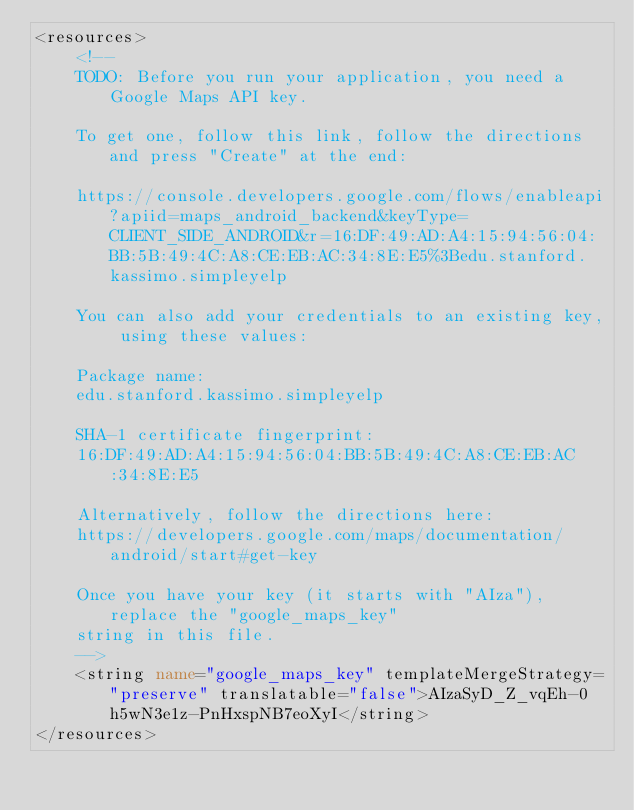<code> <loc_0><loc_0><loc_500><loc_500><_XML_><resources>
    <!--
    TODO: Before you run your application, you need a Google Maps API key.

    To get one, follow this link, follow the directions and press "Create" at the end:

    https://console.developers.google.com/flows/enableapi?apiid=maps_android_backend&keyType=CLIENT_SIDE_ANDROID&r=16:DF:49:AD:A4:15:94:56:04:BB:5B:49:4C:A8:CE:EB:AC:34:8E:E5%3Bedu.stanford.kassimo.simpleyelp

    You can also add your credentials to an existing key, using these values:

    Package name:
    edu.stanford.kassimo.simpleyelp

    SHA-1 certificate fingerprint:
    16:DF:49:AD:A4:15:94:56:04:BB:5B:49:4C:A8:CE:EB:AC:34:8E:E5

    Alternatively, follow the directions here:
    https://developers.google.com/maps/documentation/android/start#get-key

    Once you have your key (it starts with "AIza"), replace the "google_maps_key"
    string in this file.
    -->
    <string name="google_maps_key" templateMergeStrategy="preserve" translatable="false">AIzaSyD_Z_vqEh-0h5wN3e1z-PnHxspNB7eoXyI</string>
</resources></code> 